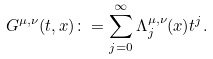<formula> <loc_0><loc_0><loc_500><loc_500>G ^ { \mu , \nu } ( t , x ) \colon = \sum _ { j = 0 } ^ { \infty } { \Lambda _ { j } ^ { \mu , \nu } ( x ) t ^ { j } } .</formula> 